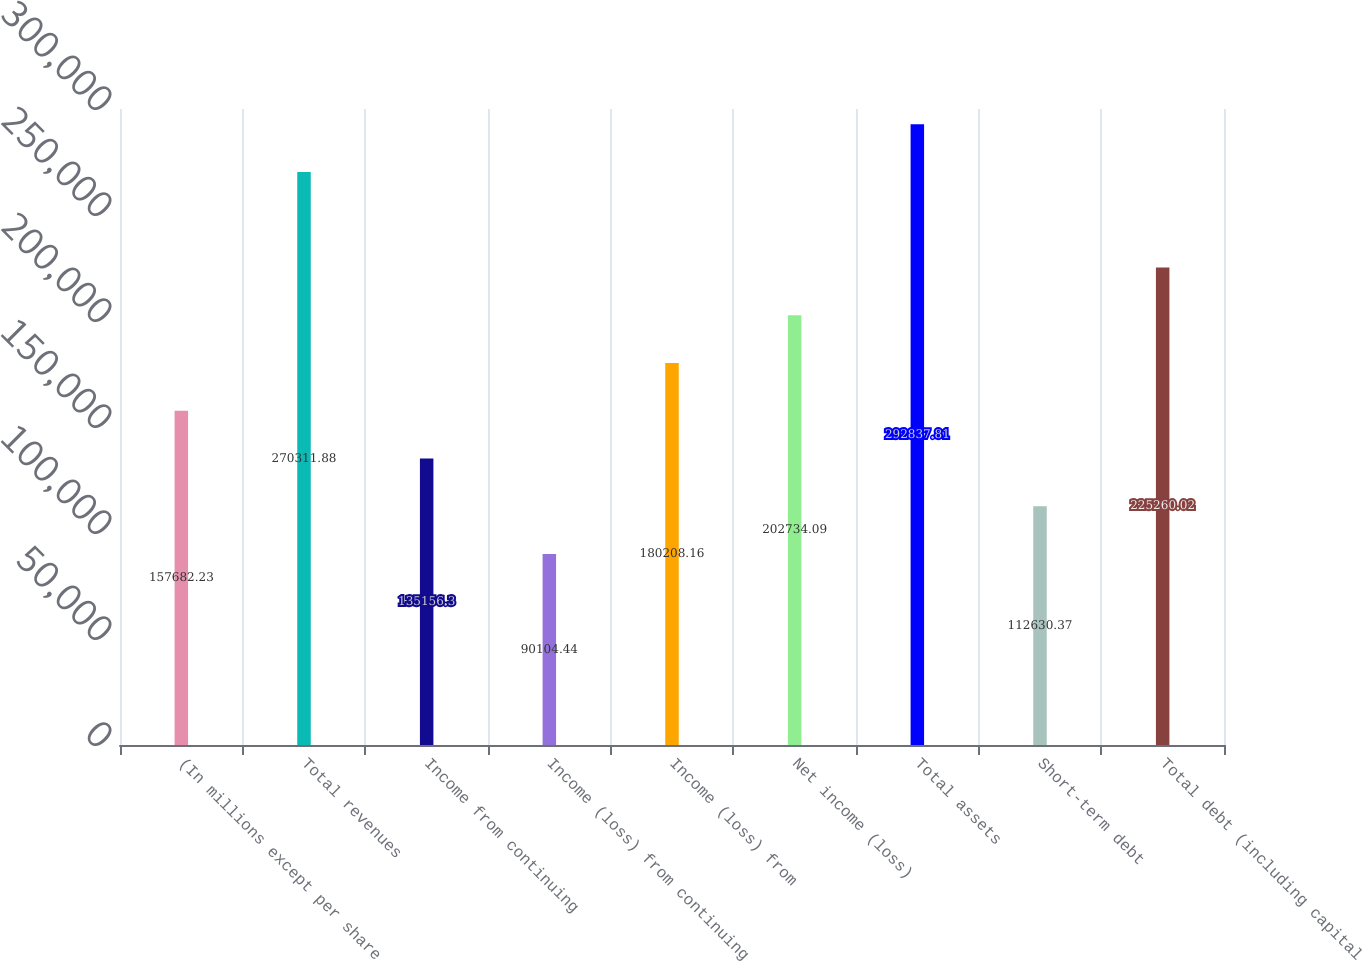Convert chart to OTSL. <chart><loc_0><loc_0><loc_500><loc_500><bar_chart><fcel>(In millions except per share<fcel>Total revenues<fcel>Income from continuing<fcel>Income (loss) from continuing<fcel>Income (loss) from<fcel>Net income (loss)<fcel>Total assets<fcel>Short-term debt<fcel>Total debt (including capital<nl><fcel>157682<fcel>270312<fcel>135156<fcel>90104.4<fcel>180208<fcel>202734<fcel>292838<fcel>112630<fcel>225260<nl></chart> 